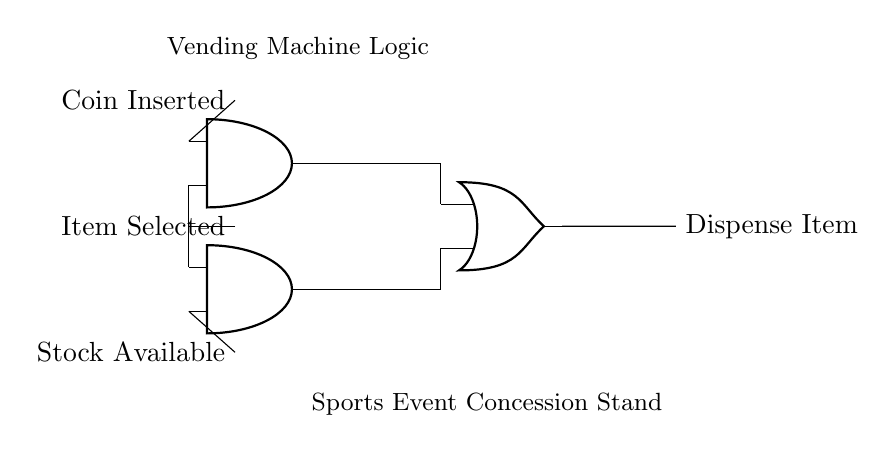What are the inputs to the logic gates? The inputs to the logic gates are "Coin Inserted", "Item Selected", and "Stock Available". These labels show what conditions the gates will evaluate.
Answer: Coin Inserted, Item Selected, Stock Available How many AND gates are in the circuit? The diagram shows two AND gates depicted in the circuit, which are used to evaluate certain conditions simultaneously.
Answer: 2 What is the output of the OR gate? The output of the OR gate is labeled as "Dispense Item". It indicates the final action taken when the conditions of the input gates are satisfied.
Answer: Dispense Item Under what conditions will the vending machine dispense an item? The vending machine will dispense an item if either both conditions of the first AND gate (coin inserted and an item selected) or both conditions of the second AND gate (item selected and stock available) are true, as indicated by how the gates are wired.
Answer: Coin Inserted and Item Selected or Item Selected and Stock Available What logic gates are used in this circuit? The circuit uses AND gates and an OR gate. This combination creates a logic structure to process the vending machine's operation.
Answer: AND, OR 